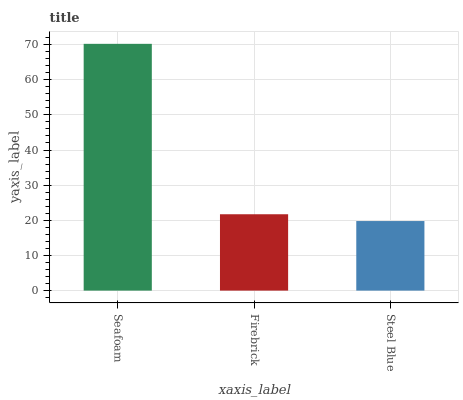Is Steel Blue the minimum?
Answer yes or no. Yes. Is Seafoam the maximum?
Answer yes or no. Yes. Is Firebrick the minimum?
Answer yes or no. No. Is Firebrick the maximum?
Answer yes or no. No. Is Seafoam greater than Firebrick?
Answer yes or no. Yes. Is Firebrick less than Seafoam?
Answer yes or no. Yes. Is Firebrick greater than Seafoam?
Answer yes or no. No. Is Seafoam less than Firebrick?
Answer yes or no. No. Is Firebrick the high median?
Answer yes or no. Yes. Is Firebrick the low median?
Answer yes or no. Yes. Is Steel Blue the high median?
Answer yes or no. No. Is Steel Blue the low median?
Answer yes or no. No. 